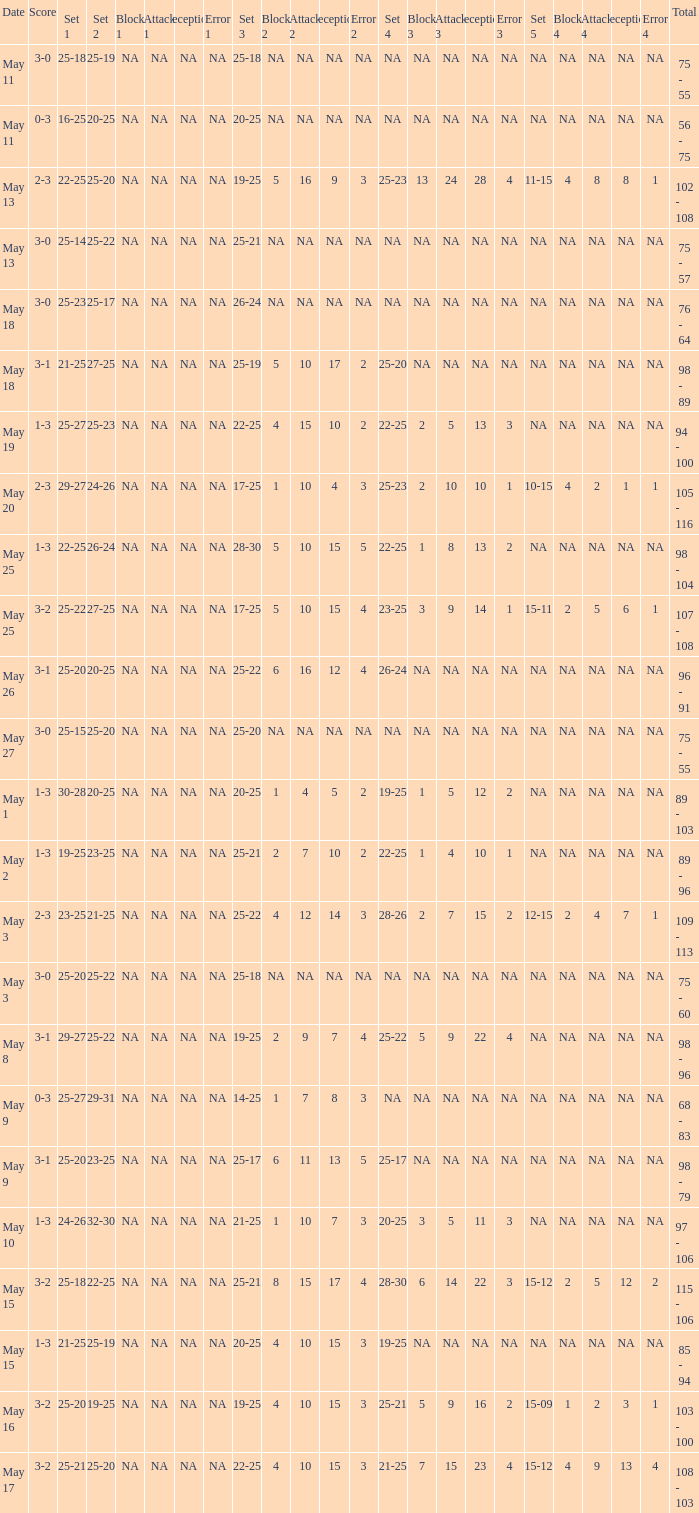What does set 2 comprise of, with 1 set of 21-25, and 4 sets of 25-20? 27-25. 